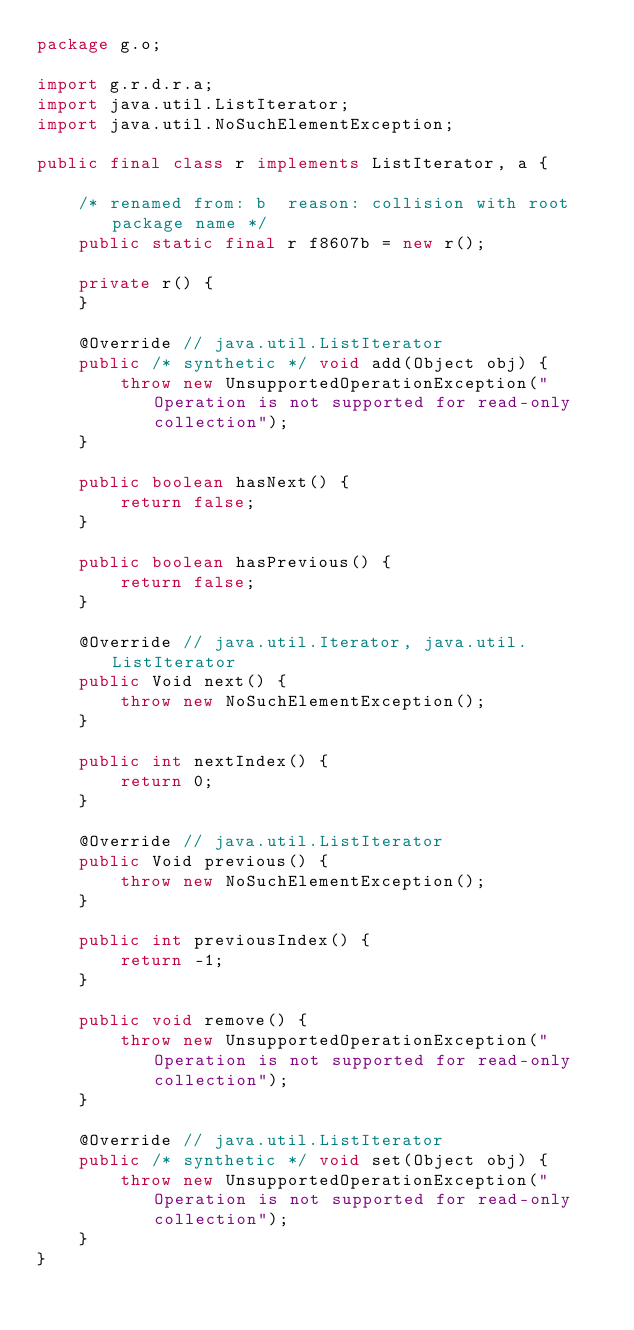<code> <loc_0><loc_0><loc_500><loc_500><_Java_>package g.o;

import g.r.d.r.a;
import java.util.ListIterator;
import java.util.NoSuchElementException;

public final class r implements ListIterator, a {

    /* renamed from: b  reason: collision with root package name */
    public static final r f8607b = new r();

    private r() {
    }

    @Override // java.util.ListIterator
    public /* synthetic */ void add(Object obj) {
        throw new UnsupportedOperationException("Operation is not supported for read-only collection");
    }

    public boolean hasNext() {
        return false;
    }

    public boolean hasPrevious() {
        return false;
    }

    @Override // java.util.Iterator, java.util.ListIterator
    public Void next() {
        throw new NoSuchElementException();
    }

    public int nextIndex() {
        return 0;
    }

    @Override // java.util.ListIterator
    public Void previous() {
        throw new NoSuchElementException();
    }

    public int previousIndex() {
        return -1;
    }

    public void remove() {
        throw new UnsupportedOperationException("Operation is not supported for read-only collection");
    }

    @Override // java.util.ListIterator
    public /* synthetic */ void set(Object obj) {
        throw new UnsupportedOperationException("Operation is not supported for read-only collection");
    }
}
</code> 